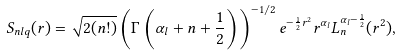Convert formula to latex. <formula><loc_0><loc_0><loc_500><loc_500>S _ { n l q } ( r ) = \sqrt { 2 ( n ! ) } \left ( \Gamma \left ( \alpha _ { l } + n + \frac { 1 } { 2 } \right ) \right ) ^ { - 1 / 2 } e ^ { - \frac { 1 } { 2 } r ^ { 2 } } r ^ { \alpha _ { l } } L _ { n } ^ { \alpha _ { l } - \frac { 1 } { 2 } } ( r ^ { 2 } ) ,</formula> 